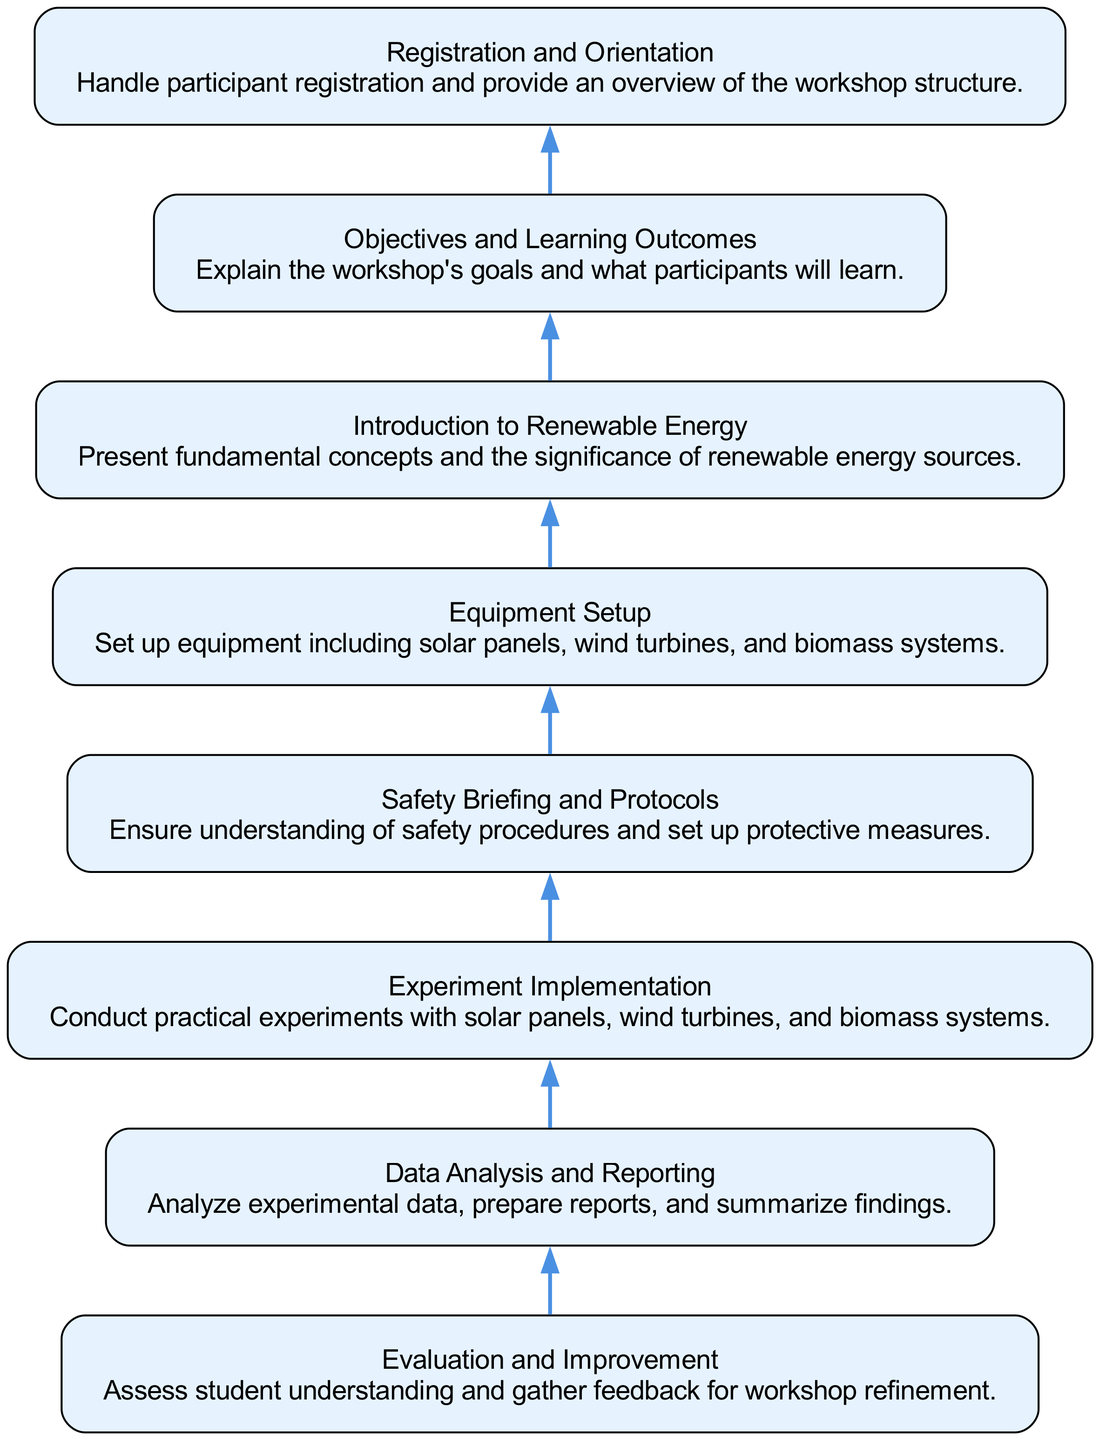What is the last step in the workshop implementation process? The last step, according to the flow chart, is "Evaluation and Improvement," which indicates that after all other processes are completed, the workshop is assessed for effectiveness.
Answer: Evaluation and Improvement How many nodes are present in the diagram? By counting the distinct elements represented in the diagram, it is evident that there are 8 nodes corresponding to the provided workshop activities.
Answer: 8 Which step comes before "Data Analysis and Reporting"? In the flow of the diagram, "Experiment Implementation" is indicated as the step that directly precedes "Data Analysis and Reporting."
Answer: Experiment Implementation What is the purpose of the "Safety Briefing and Protocols" node? The node describes the importance of ensuring that all participants understand safety procedures and protective measures before conducting experiments, which is vital for a practical workshop.
Answer: Ensure understanding of safety procedures Which node represents the foundation of workshop knowledge? The node "Introduction to Renewable Energy" serves as the foundation by presenting the fundamental concepts and significance of renewable energy sources necessary for participants.
Answer: Introduction to Renewable Energy What is the relationship between "Objectives and Learning Outcomes" and "Experiment Implementation"? The flow chart indicates that "Objectives and Learning Outcomes" set the stage for what participants will learn, which subsequently prepares them for the hands-on experience through "Experiment Implementation."
Answer: Precedes in flow What is the first activity participants engage in during the workshop? The diagram indicates that the first activity for participants is "Registration and Orientation," which involves managing participant registration and overviewing workshop structure.
Answer: Registration and Orientation How many steps are there between "Equipment Setup" and "Data Analysis and Reporting"? Counting the steps in between, there are 3 steps: "Experiment Implementation," "Safety Briefing and Protocols," and "Data Analysis and Reporting," making it a total of three intermediary steps.
Answer: 3 Which node highlights the goals of the workshop? The node titled "Objectives and Learning Outcomes" summarizes the workshop's goals and what participants are expected to learn during their engagement.
Answer: Objectives and Learning Outcomes 